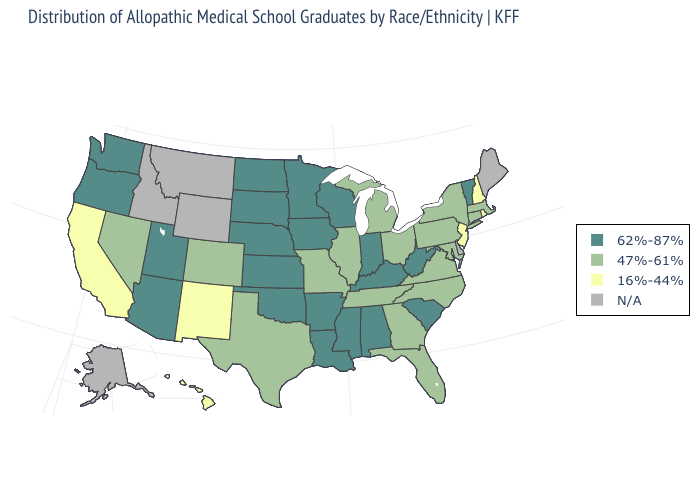What is the value of Maryland?
Give a very brief answer. 47%-61%. Does the first symbol in the legend represent the smallest category?
Be succinct. No. Is the legend a continuous bar?
Concise answer only. No. Name the states that have a value in the range N/A?
Be succinct. Alaska, Delaware, Idaho, Maine, Montana, Wyoming. Which states hav the highest value in the Northeast?
Concise answer only. Vermont. How many symbols are there in the legend?
Be succinct. 4. Does South Carolina have the highest value in the South?
Short answer required. Yes. Name the states that have a value in the range 16%-44%?
Give a very brief answer. California, Hawaii, New Hampshire, New Jersey, New Mexico, Rhode Island. Name the states that have a value in the range N/A?
Concise answer only. Alaska, Delaware, Idaho, Maine, Montana, Wyoming. Which states have the lowest value in the USA?
Write a very short answer. California, Hawaii, New Hampshire, New Jersey, New Mexico, Rhode Island. Is the legend a continuous bar?
Concise answer only. No. What is the highest value in the Northeast ?
Give a very brief answer. 62%-87%. What is the highest value in states that border North Dakota?
Be succinct. 62%-87%. 